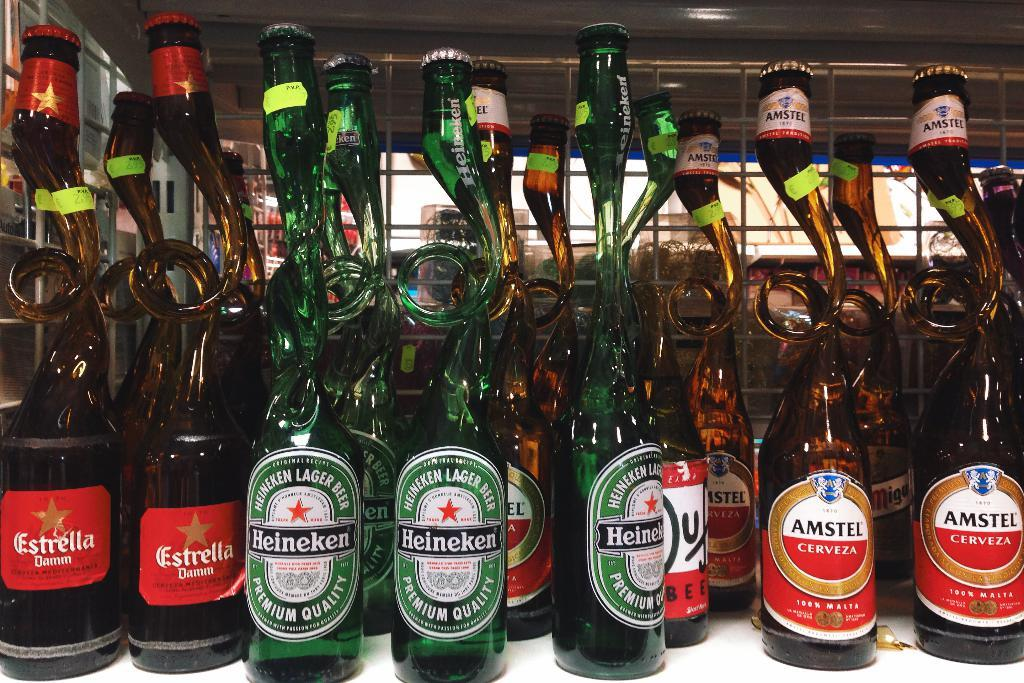<image>
Offer a succinct explanation of the picture presented. Estrella, Heineken, and Amstel beers placed on top of a table. 